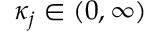Convert formula to latex. <formula><loc_0><loc_0><loc_500><loc_500>\kappa _ { j } \in ( 0 , \infty )</formula> 